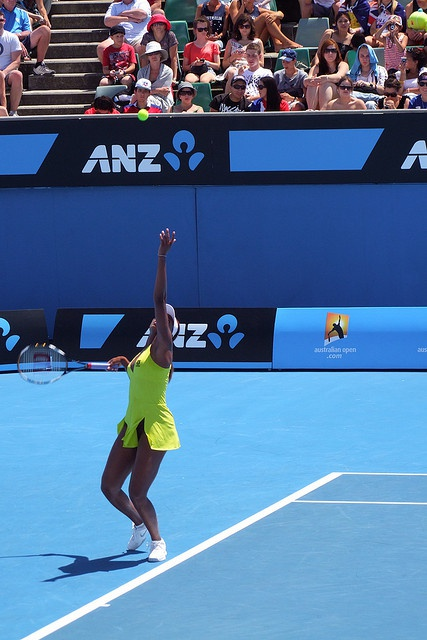Describe the objects in this image and their specific colors. I can see people in brown, black, green, navy, and purple tones, people in brown, black, and maroon tones, tennis racket in brown, lightblue, navy, darkblue, and black tones, people in brown, black, and maroon tones, and people in brown, black, and maroon tones in this image. 